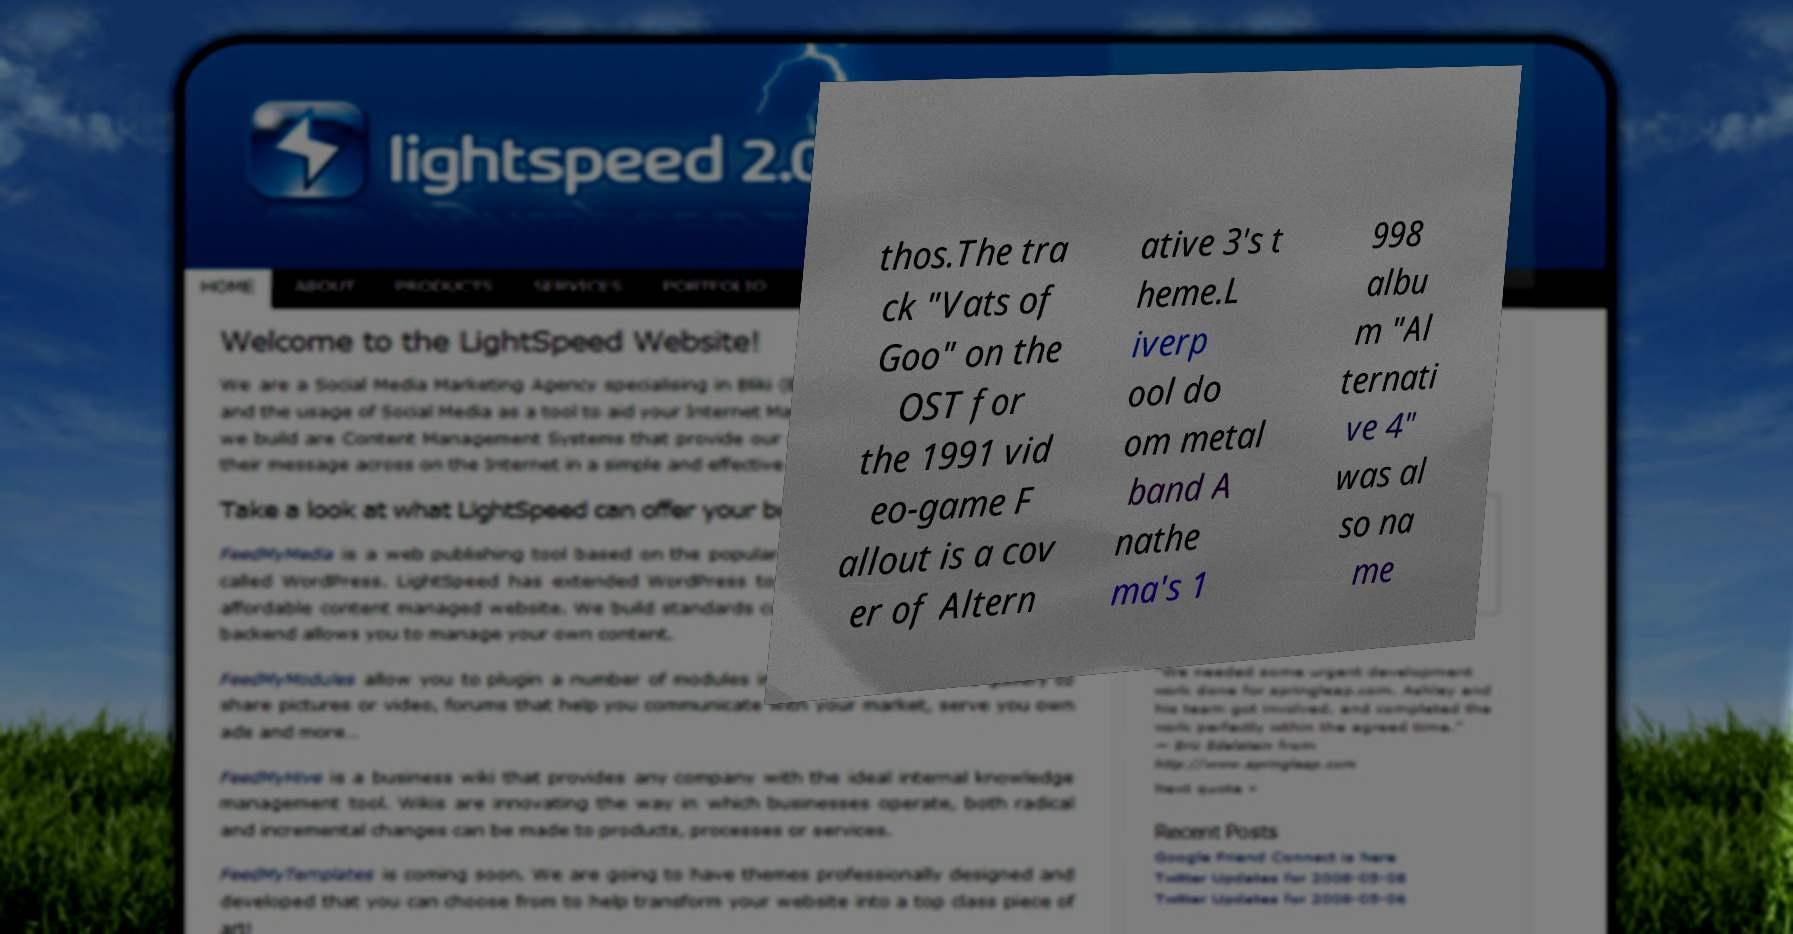Please read and relay the text visible in this image. What does it say? thos.The tra ck "Vats of Goo" on the OST for the 1991 vid eo-game F allout is a cov er of Altern ative 3's t heme.L iverp ool do om metal band A nathe ma's 1 998 albu m "Al ternati ve 4" was al so na me 